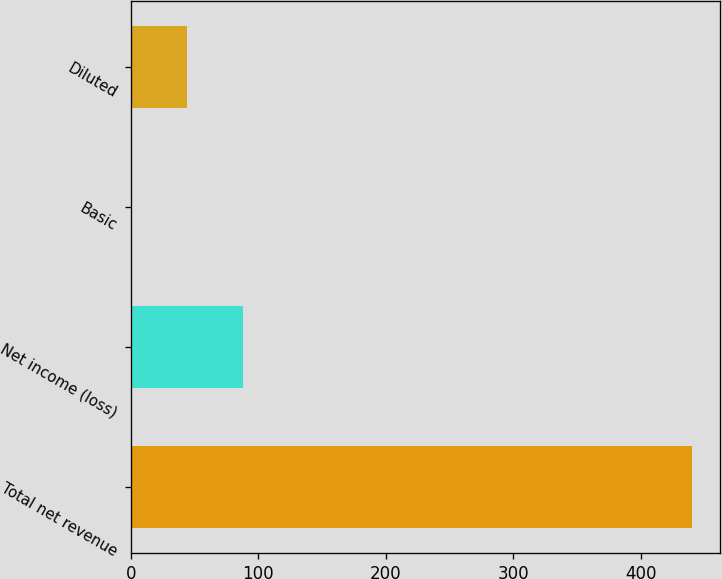Convert chart to OTSL. <chart><loc_0><loc_0><loc_500><loc_500><bar_chart><fcel>Total net revenue<fcel>Net income (loss)<fcel>Basic<fcel>Diluted<nl><fcel>440<fcel>88.15<fcel>0.19<fcel>44.17<nl></chart> 